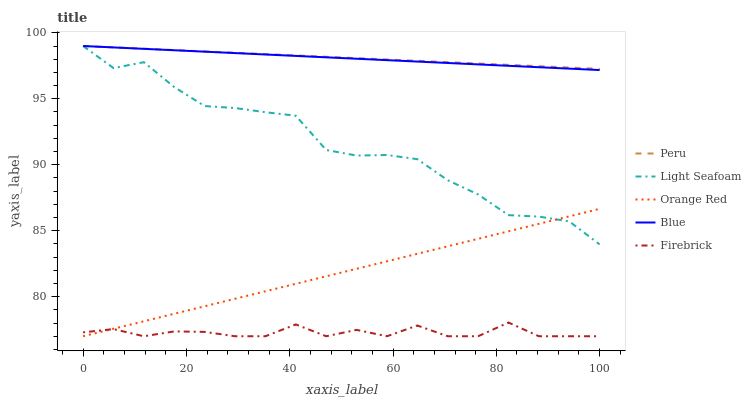Does Firebrick have the minimum area under the curve?
Answer yes or no. Yes. Does Peru have the maximum area under the curve?
Answer yes or no. Yes. Does Light Seafoam have the minimum area under the curve?
Answer yes or no. No. Does Light Seafoam have the maximum area under the curve?
Answer yes or no. No. Is Peru the smoothest?
Answer yes or no. Yes. Is Light Seafoam the roughest?
Answer yes or no. Yes. Is Firebrick the smoothest?
Answer yes or no. No. Is Firebrick the roughest?
Answer yes or no. No. Does Firebrick have the lowest value?
Answer yes or no. Yes. Does Light Seafoam have the lowest value?
Answer yes or no. No. Does Peru have the highest value?
Answer yes or no. Yes. Does Firebrick have the highest value?
Answer yes or no. No. Is Orange Red less than Blue?
Answer yes or no. Yes. Is Blue greater than Firebrick?
Answer yes or no. Yes. Does Blue intersect Light Seafoam?
Answer yes or no. Yes. Is Blue less than Light Seafoam?
Answer yes or no. No. Is Blue greater than Light Seafoam?
Answer yes or no. No. Does Orange Red intersect Blue?
Answer yes or no. No. 